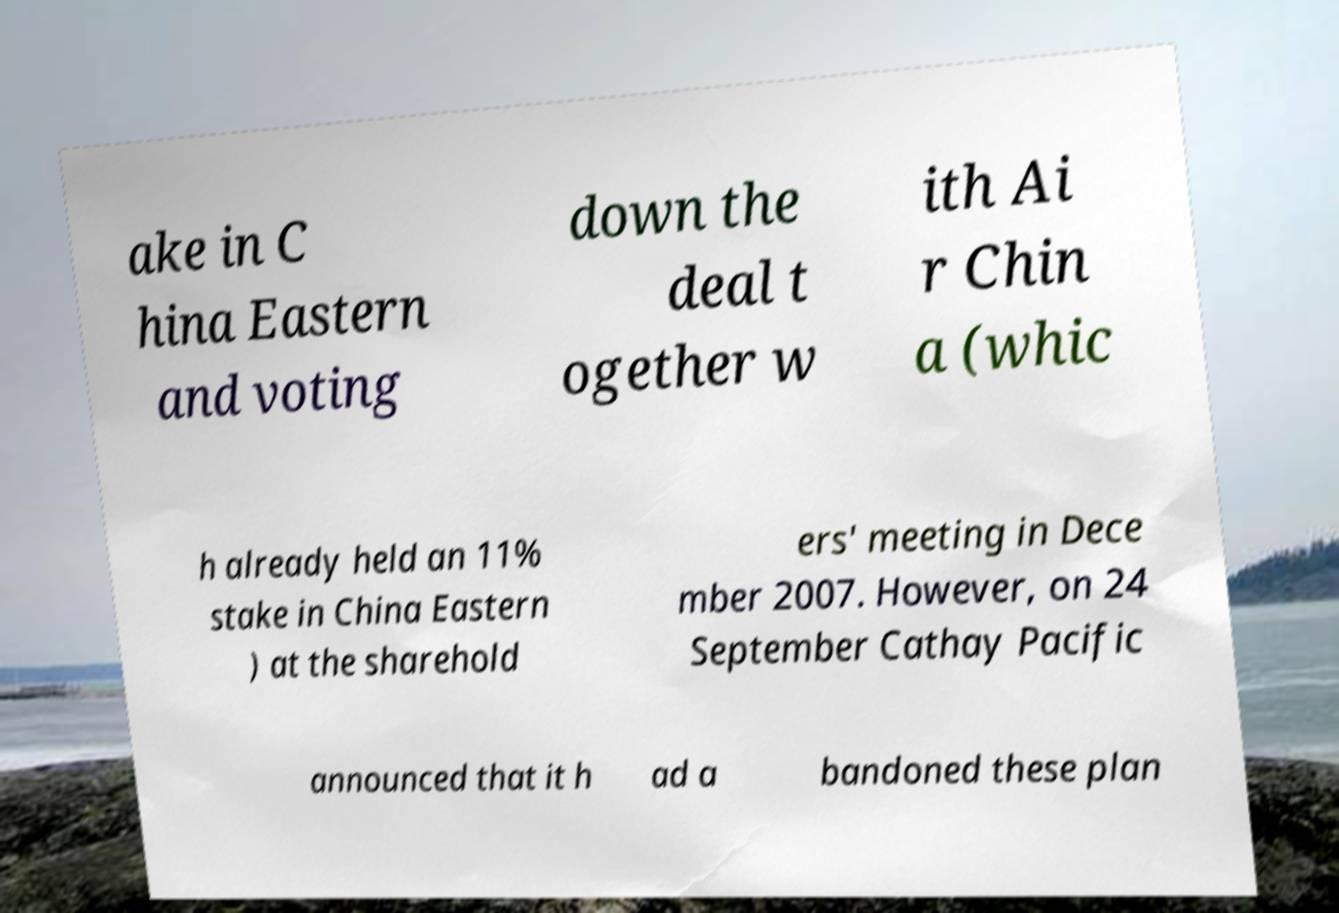Please read and relay the text visible in this image. What does it say? ake in C hina Eastern and voting down the deal t ogether w ith Ai r Chin a (whic h already held an 11% stake in China Eastern ) at the sharehold ers' meeting in Dece mber 2007. However, on 24 September Cathay Pacific announced that it h ad a bandoned these plan 